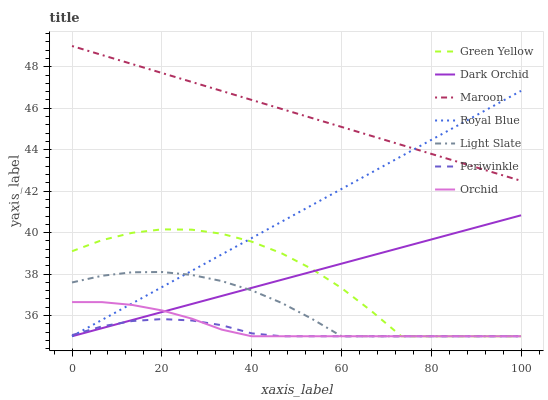Does Periwinkle have the minimum area under the curve?
Answer yes or no. Yes. Does Maroon have the maximum area under the curve?
Answer yes or no. Yes. Does Royal Blue have the minimum area under the curve?
Answer yes or no. No. Does Royal Blue have the maximum area under the curve?
Answer yes or no. No. Is Maroon the smoothest?
Answer yes or no. Yes. Is Green Yellow the roughest?
Answer yes or no. Yes. Is Royal Blue the smoothest?
Answer yes or no. No. Is Royal Blue the roughest?
Answer yes or no. No. Does Light Slate have the lowest value?
Answer yes or no. Yes. Does Maroon have the lowest value?
Answer yes or no. No. Does Maroon have the highest value?
Answer yes or no. Yes. Does Royal Blue have the highest value?
Answer yes or no. No. Is Green Yellow less than Maroon?
Answer yes or no. Yes. Is Maroon greater than Periwinkle?
Answer yes or no. Yes. Does Royal Blue intersect Maroon?
Answer yes or no. Yes. Is Royal Blue less than Maroon?
Answer yes or no. No. Is Royal Blue greater than Maroon?
Answer yes or no. No. Does Green Yellow intersect Maroon?
Answer yes or no. No. 